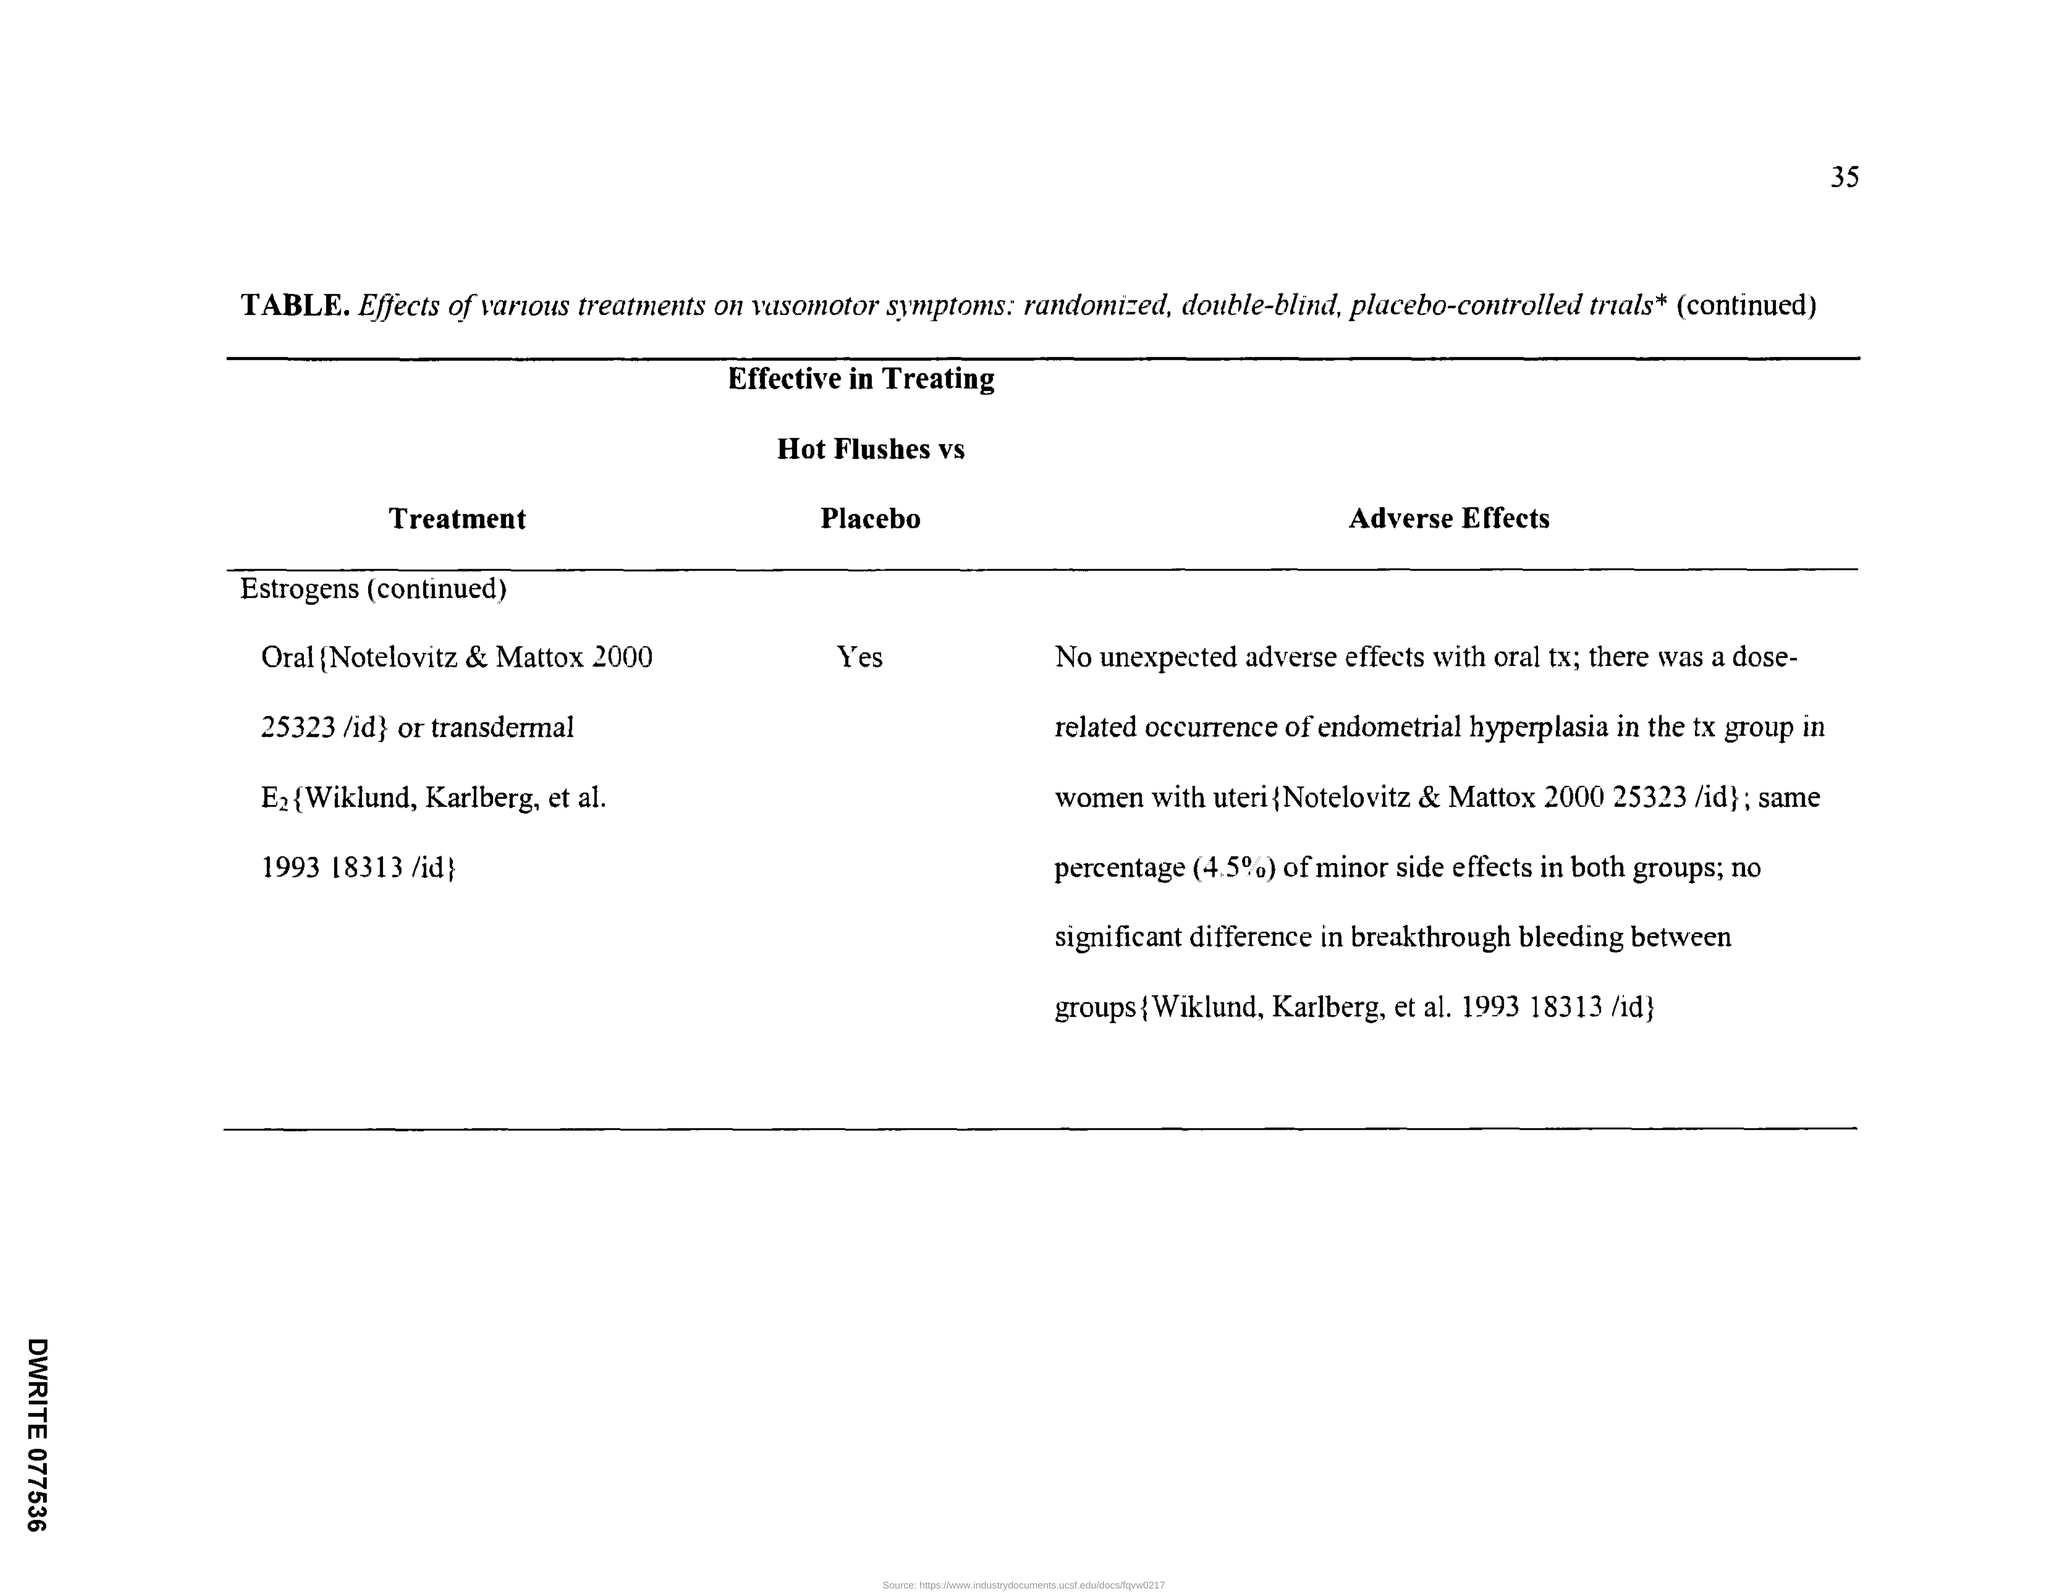What is the Page Number?
Ensure brevity in your answer.  35. Is estrogen effective in treating Hot flushes vs Placebo?
Your answer should be compact. Yes. 